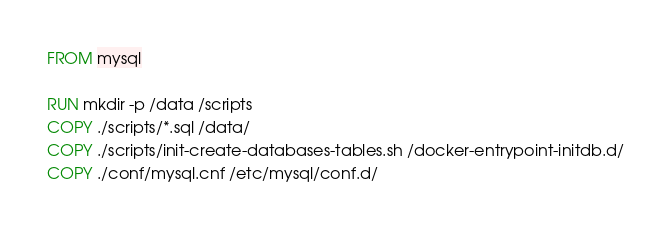<code> <loc_0><loc_0><loc_500><loc_500><_Dockerfile_>FROM mysql

RUN mkdir -p /data /scripts
COPY ./scripts/*.sql /data/
COPY ./scripts/init-create-databases-tables.sh /docker-entrypoint-initdb.d/
COPY ./conf/mysql.cnf /etc/mysql/conf.d/
</code> 